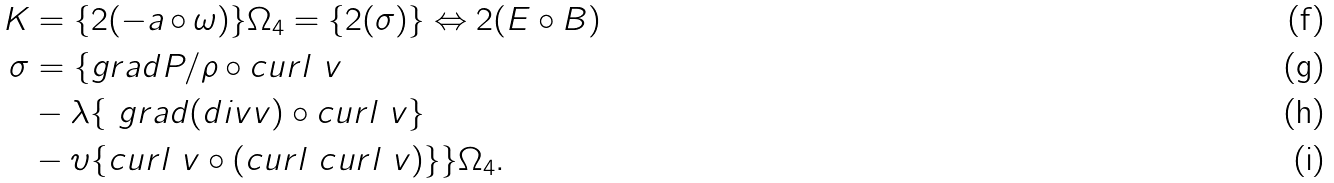Convert formula to latex. <formula><loc_0><loc_0><loc_500><loc_500>K & = \{ 2 ( - a \circ \omega ) \} \Omega _ { 4 } = \{ 2 ( \sigma ) \} \Leftrightarrow 2 ( E \circ B ) \\ \sigma & = \{ g r a d P / \rho \circ c u r l \ v \\ & - \lambda \{ \ g r a d ( d i v v ) \circ c u r l \ v \} \\ & - \upsilon \{ c u r l \ v \circ ( c u r l \ c u r l \ v ) \} \} \Omega _ { 4 } .</formula> 